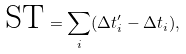Convert formula to latex. <formula><loc_0><loc_0><loc_500><loc_500>\text {ST} = \sum _ { i } ( \Delta t ^ { \prime } _ { i } - \Delta t _ { i } ) ,</formula> 